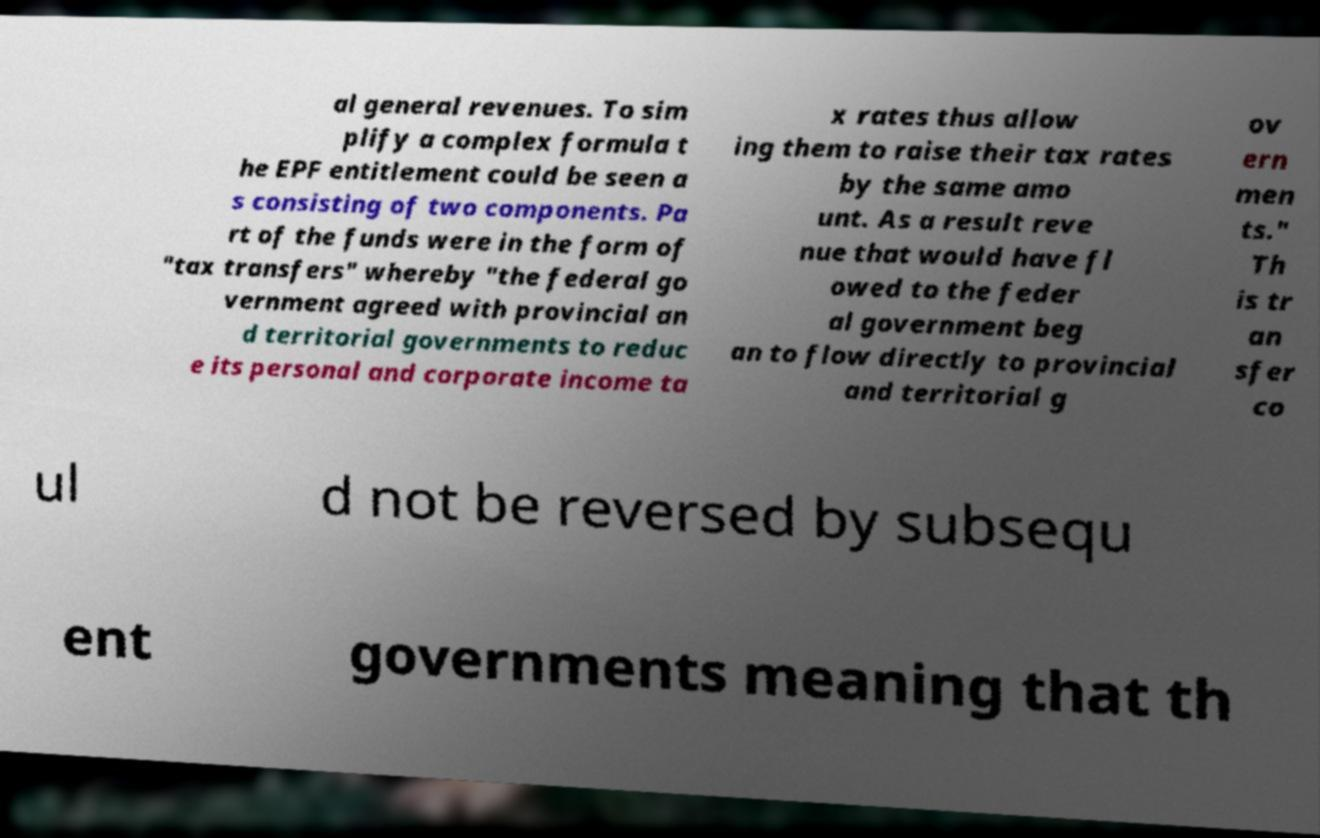I need the written content from this picture converted into text. Can you do that? al general revenues. To sim plify a complex formula t he EPF entitlement could be seen a s consisting of two components. Pa rt of the funds were in the form of "tax transfers" whereby "the federal go vernment agreed with provincial an d territorial governments to reduc e its personal and corporate income ta x rates thus allow ing them to raise their tax rates by the same amo unt. As a result reve nue that would have fl owed to the feder al government beg an to flow directly to provincial and territorial g ov ern men ts." Th is tr an sfer co ul d not be reversed by subsequ ent governments meaning that th 